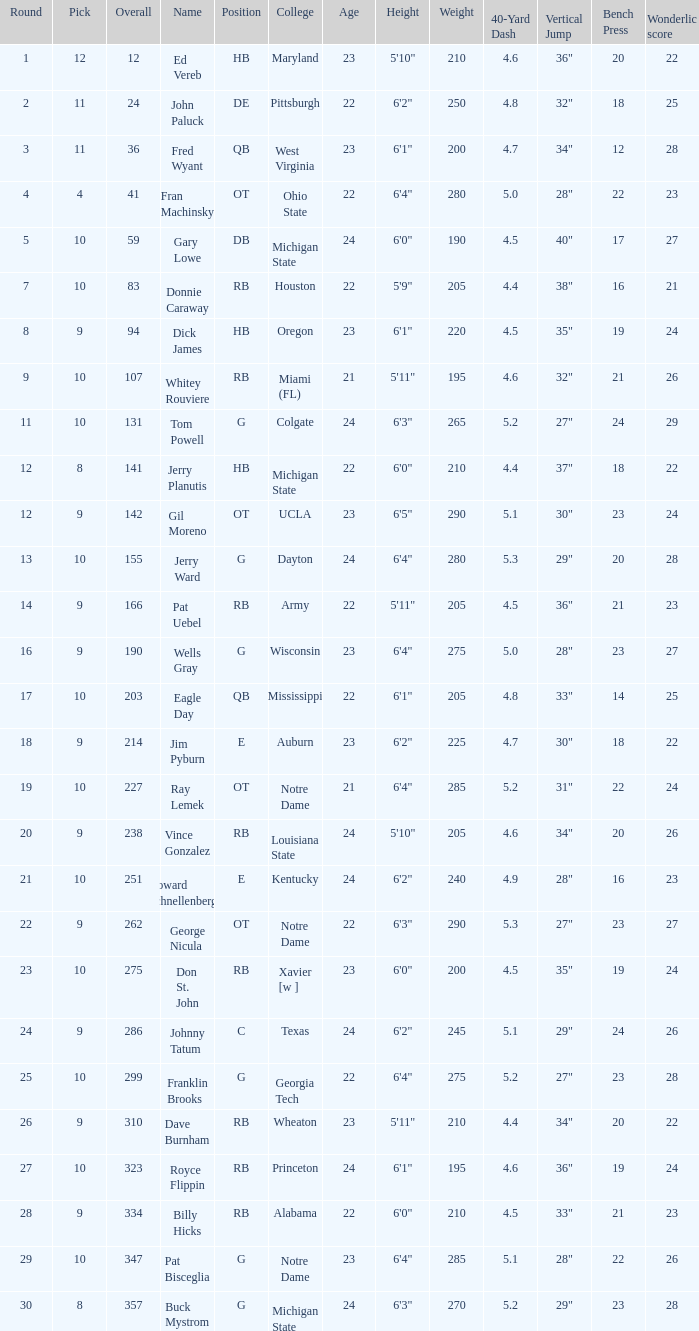What is the overall pick number for a draft pick smaller than 9, named buck mystrom from Michigan State college? 357.0. 